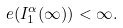<formula> <loc_0><loc_0><loc_500><loc_500>\ e ( I _ { 1 } ^ { \alpha } ( \infty ) ) < \infty .</formula> 